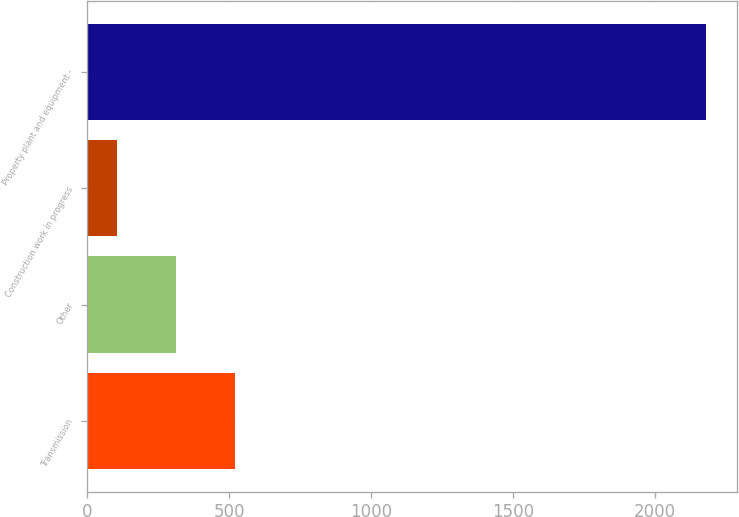Convert chart. <chart><loc_0><loc_0><loc_500><loc_500><bar_chart><fcel>Transmission<fcel>Other<fcel>Construction work in progress<fcel>Property plant and equipment -<nl><fcel>520<fcel>312.5<fcel>105<fcel>2180<nl></chart> 